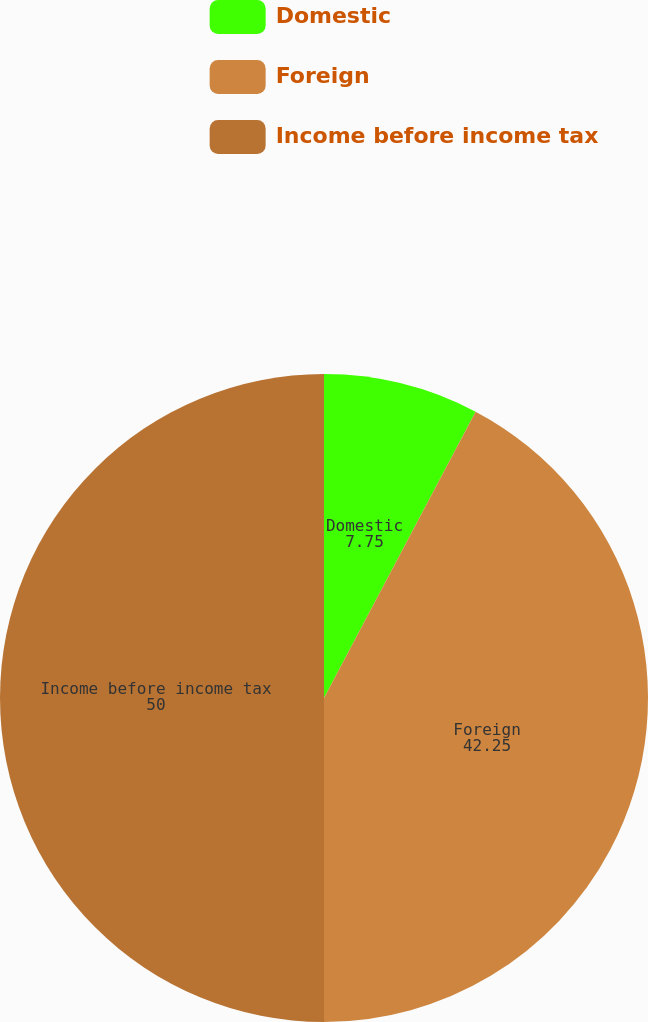Convert chart to OTSL. <chart><loc_0><loc_0><loc_500><loc_500><pie_chart><fcel>Domestic<fcel>Foreign<fcel>Income before income tax<nl><fcel>7.75%<fcel>42.25%<fcel>50.0%<nl></chart> 